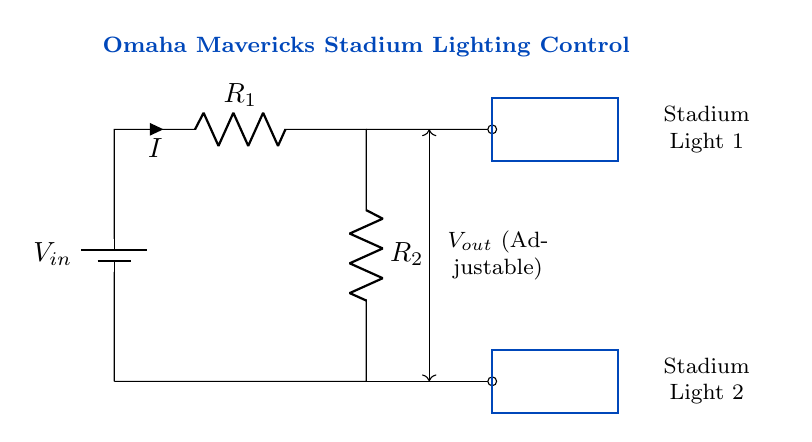What is the input voltage to the voltage divider? The circuit shows the label \( V_{in} \) on the battery source, indicating it is the input voltage.
Answer: \( V_{in} \) What are the resistances used in this circuit? The diagram labels two resistors, \( R_1 \) and \( R_2 \), showing they are the only two resistive components present in the voltage divider.
Answer: \( R_1 \), \( R_2 \) What does \( V_{out} \) represent in this circuit? The label \( V_{out} \) indicates the output voltage, which is adjustable for controlling the brightness of the stadium lights connected to the circuit.
Answer: \( V_{out} \) How many stadium lights are present in this circuit? The circuit shows two rectangles labeled as "Stadium Light 1" and "Stadium Light 2," indicating there are two lights being controlled.
Answer: 2 What affects the brightness of the stadium lights in this circuit? The brightness is adjusted by changing the output voltage \( V_{out} \), which is affected by the ratio of \( R_1 \) and \( R_2 \), making them key factors.
Answer: Resistor values What is the relationship between \( R_1 \) and \( R_2 \) in terms of output voltage? The output voltage is calculated using the voltage divider rule, which states that \( V_{out} \) is a fraction of \( V_{in} \) determined by the values of \( R_1 \) and \( R_2 \).
Answer: Voltage divider rule Can \( V_{out} \) be zero? Yes, if \( R_2 \) is significantly larger than \( R_1 \), or if there are no lights connected, \( V_{out} \) can approximate zero.
Answer: Yes 